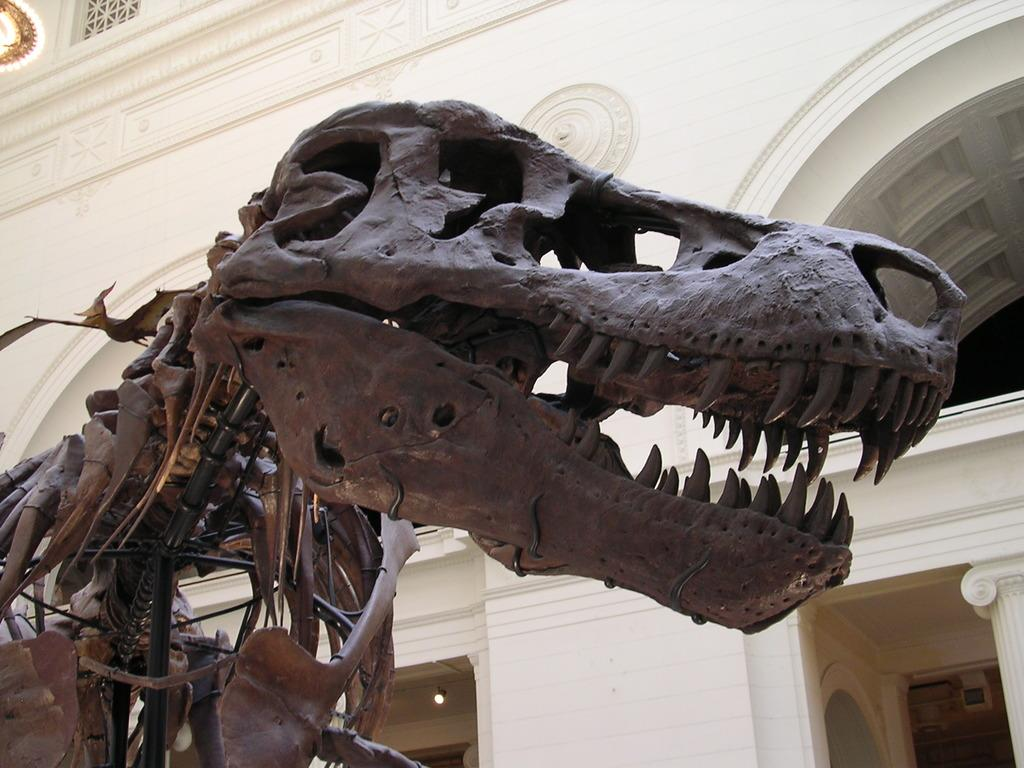What type of model can be seen in the image? There is a model of an animal in the image. What structure is also present in the image? There is a building in the image. What are the main features of the building? The building has walls, an arch, and pillars. What type of coat is the animal wearing in the image? There is no coat present in the image, as the animal is a model and not a living creature. 